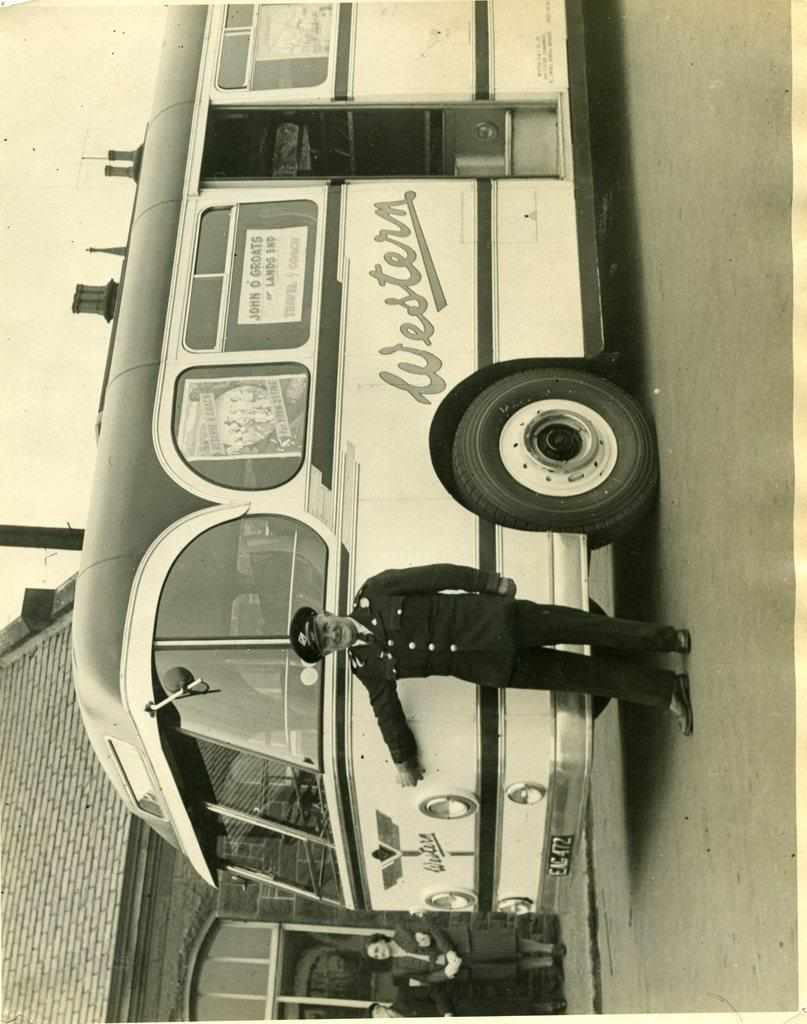What is the main subject of the image? The main subject of the image is a person standing near a bus. Can you describe the location of the bus in the image? The bus is on the road in the image. How many other people are visible in the image? There are two other persons standing in the background of the image. What can be seen in the background of the image besides the people? There is a building and the sky visible in the background of the image. What type of wing is attached to the bus in the image? There is no wing attached to the bus in the image; it is a regular bus on the road. 